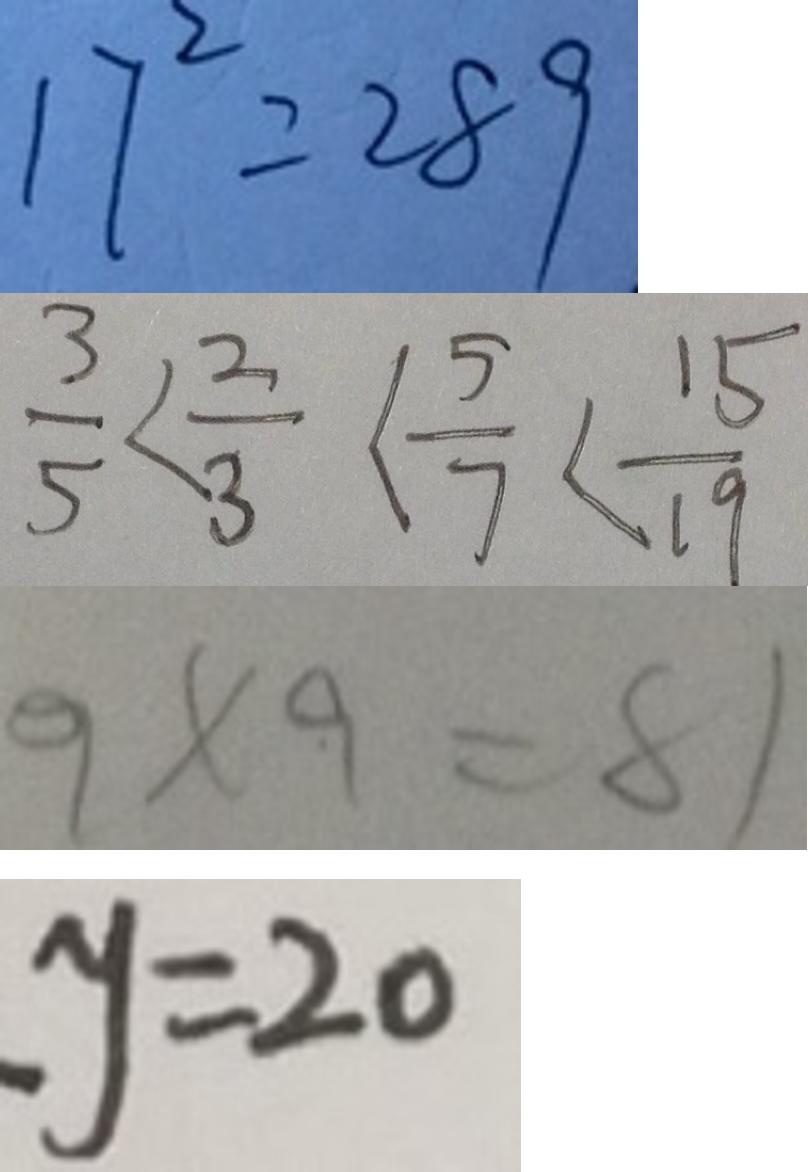Convert formula to latex. <formula><loc_0><loc_0><loc_500><loc_500>1 7 ^ { 2 } = 2 8 9 
 \frac { 3 } { 5 } < \frac { 2 } { 3 } < \frac { 5 } { 7 } < \frac { 1 5 } { 9 } 
 9 \times 9 = 8 1 
 y = 2 0</formula> 